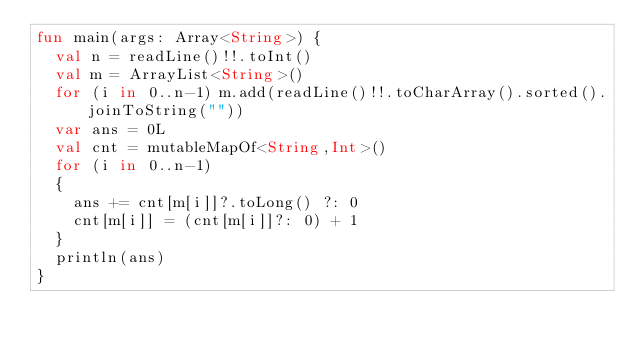<code> <loc_0><loc_0><loc_500><loc_500><_Kotlin_>fun main(args: Array<String>) {
  val n = readLine()!!.toInt()
  val m = ArrayList<String>()
  for (i in 0..n-1) m.add(readLine()!!.toCharArray().sorted().joinToString(""))
  var ans = 0L
  val cnt = mutableMapOf<String,Int>()
  for (i in 0..n-1)
  {
    ans += cnt[m[i]]?.toLong() ?: 0
    cnt[m[i]] = (cnt[m[i]]?: 0) + 1
  }
  println(ans)
}
</code> 